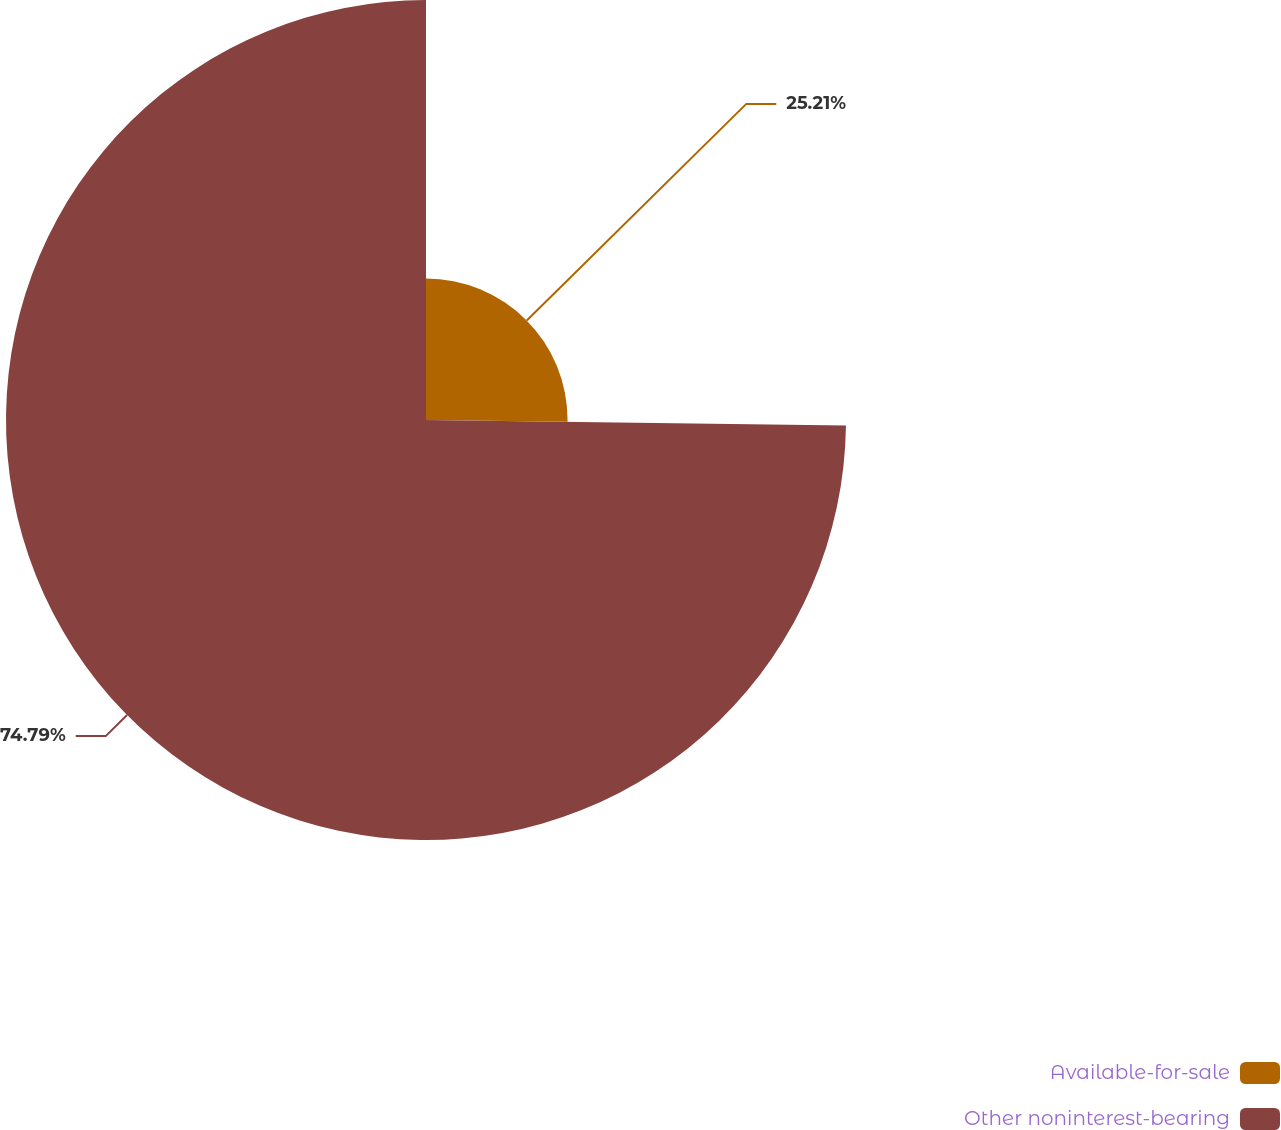Convert chart to OTSL. <chart><loc_0><loc_0><loc_500><loc_500><pie_chart><fcel>Available-for-sale<fcel>Other noninterest-bearing<nl><fcel>25.21%<fcel>74.79%<nl></chart> 